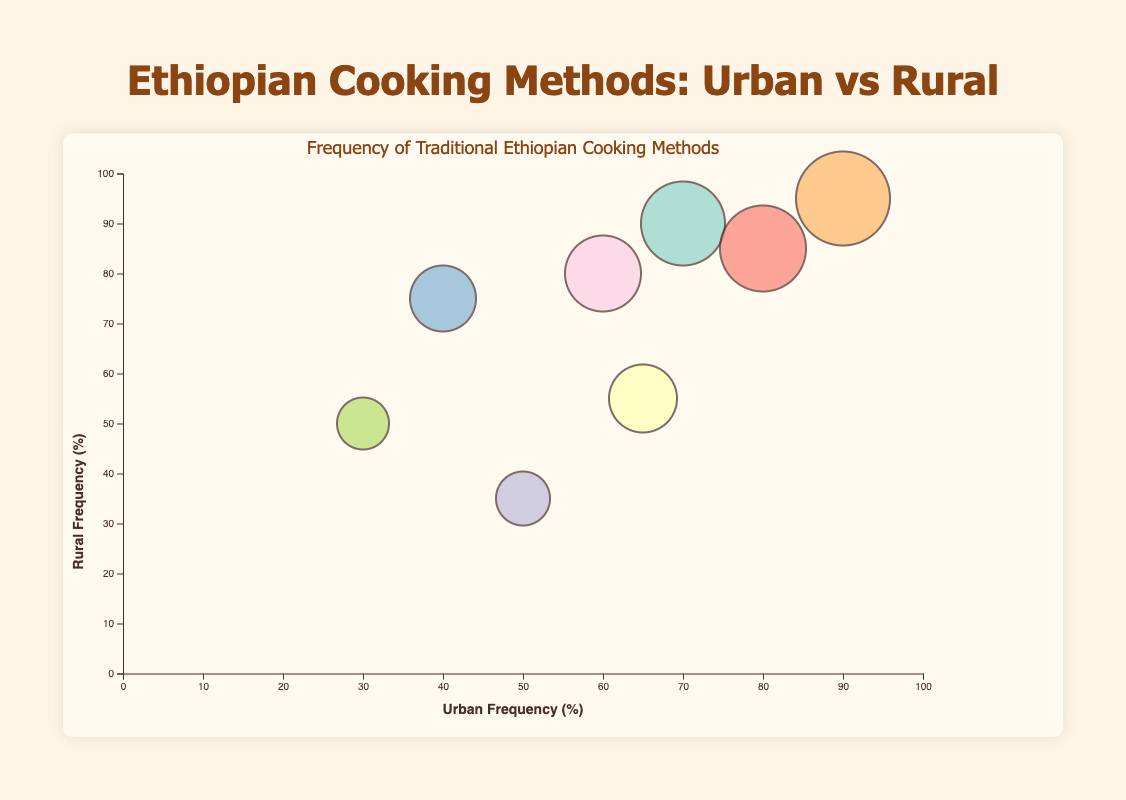What's the title of the chart? The title is usually located at the top of the chart for easy identification. By reading the top part of the chart, you can find the title.
Answer: Ethiopian Cooking Methods: Urban vs Rural How many cooking methods are compared in the chart? By counting the bubbles, each representing a different cooking method, we can determine the number of compared methods.
Answer: 8 Which cooking method has the highest urban frequency? By looking at the top end of the horizontal axis (Urban Frequency), we can see which bubble is placed the highest.
Answer: Jebena Coffee Brewing Which cooking method uses the "Mitad Stove" technique and what are the frequencies in urban and rural areas? Find the bubble that, upon hovering or looking at the tool-tip, specifies the "Mitad Stove" technique. The chart or tool-tip will indicate the frequencies.
Answer: Injera Baking uses "Mitad Stove" and the frequencies are 70% urban and 90% rural Between Doro Wat Preparation and Berbere Spice Preparation, which method is more frequently used in rural areas? Compare the rural frequencies of the two methods by looking at the vertical positions of their bubbles.
Answer: Berbere Spice Preparation (75%) What is the average frequency of urban usage for Kitfo Preparation and Tihlo Preparation? Sum the urban frequencies for these methods and divide by 2: (50 + 30) / 2.
Answer: 40% Which cooking method is more balanced in terms of similar urban and rural usage? Look for the bubble closest to the diagonal where urban frequency equals rural frequency, indicating similar usage.
Answer: Shiro Wat Cooking Which two methods have urban frequencies of 65% or more? Examine the horizontal axis to find methods with urban frequencies >= 65% and identify the corresponding bubbles.
Answer: Injera Baking, Doro Wat Preparation, Shiro Wat Cooking, Jebena Coffee Brewing What are the rural and urban frequencies for Firfir Making, and what technique does it use? Find the bubble representing Firfir Making, and either hover over it or read tool-tip for its details.
Answer: Firfir Making has 80% rural and 60% urban frequencies, using the "Stir-frying Leftover Injera" technique 